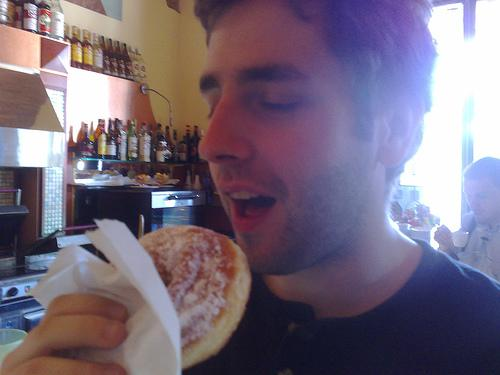Identify the main objects in the image and the notable features of the person performing the action. The main objects are a sugar-coated doughnut, a white napkin, a coffee cup, and a man with a three o'clock shadow and salt and pepper hair. What is the man wearing and what is he about to do? The man, wearing a round-necked black shirt, is about to eat a donut while holding a cup of coffee. Provide a brief summary of the prominent action happening in the image. A man with salt and pepper hair, wearing a black shirt, is eating a sugar-dusted donut while holding a white cup of coffee. Mention the central figure in the picture and their most noticeable features. The central figure is a man with closed eyes, a big nose, and facial hair, enjoying a sugar-covered donut and a cup of coffee. Describe the primary activity and the surrounding elements in the image. A man savors a scrumptious sugar-dusted donut while being surrounded by shelves filled with bottled products and bright sunlight streaming through a window. What is the person in the image doing, and what are they holding? The person is consuming a sugary donut and holding a white coffee cup in their hand. Paint a vivid picture of the scenario depicted in the image. In a cozy setting, a man indulges in a sugar-encrusted doughnut and warm coffee while gleeful rays of sunlight filter through the window, illuminating a shelf stocked with flavored syrups and bottles. Mention the primary details of the scene and the individual captured in the photograph. A man with distinguishing features like a big nose, salt and pepper hair, and a black shirt is eating a sugar-covered doughnut while holding a white coffee cup. List the main elements and actions captured in the image. Man eating a sugar-coated donut, holding a white cup, shelves with various bottles, sunlight through a window, and a restaurant-grade oven. Describe the demeanor and characteristics of the person in the image. The man, with closed eyes and subtle facial hair, appears to be enjoying a well-earned moment of bliss as he indulges in his sugar-coated treat and coffee. 